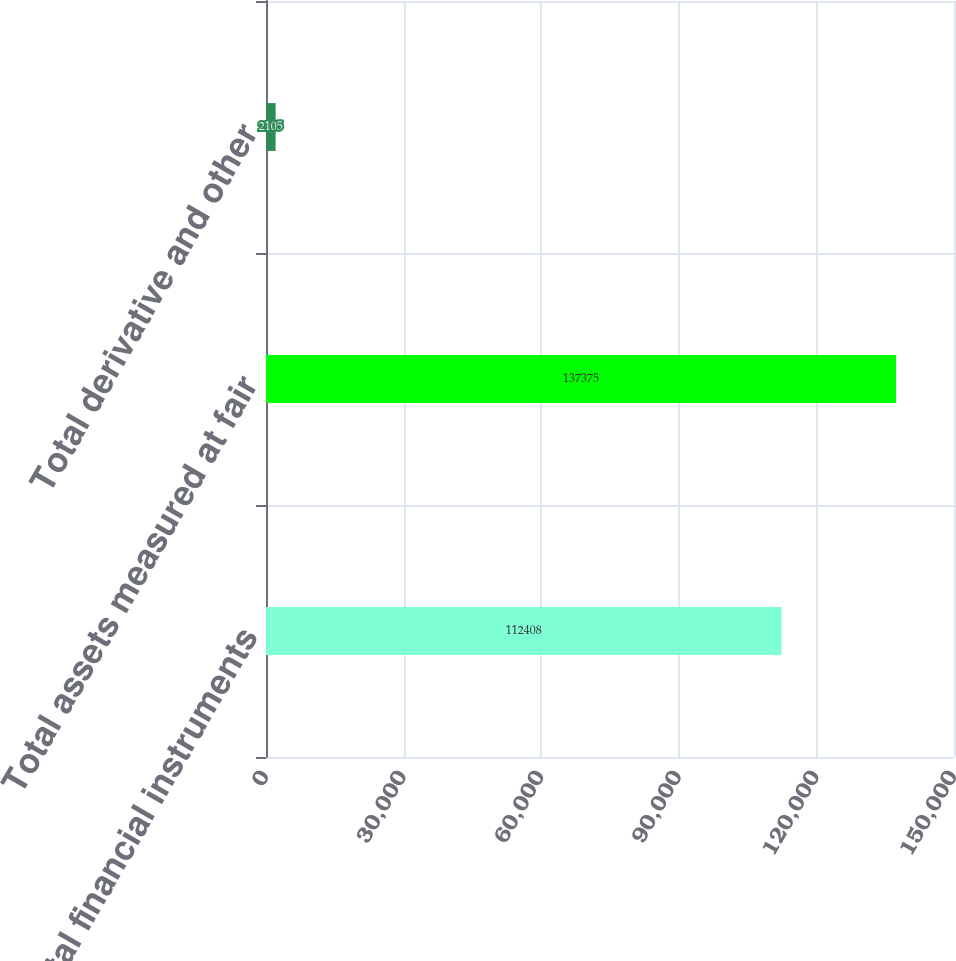<chart> <loc_0><loc_0><loc_500><loc_500><bar_chart><fcel>Total financial instruments<fcel>Total assets measured at fair<fcel>Total derivative and other<nl><fcel>112408<fcel>137375<fcel>2105<nl></chart> 